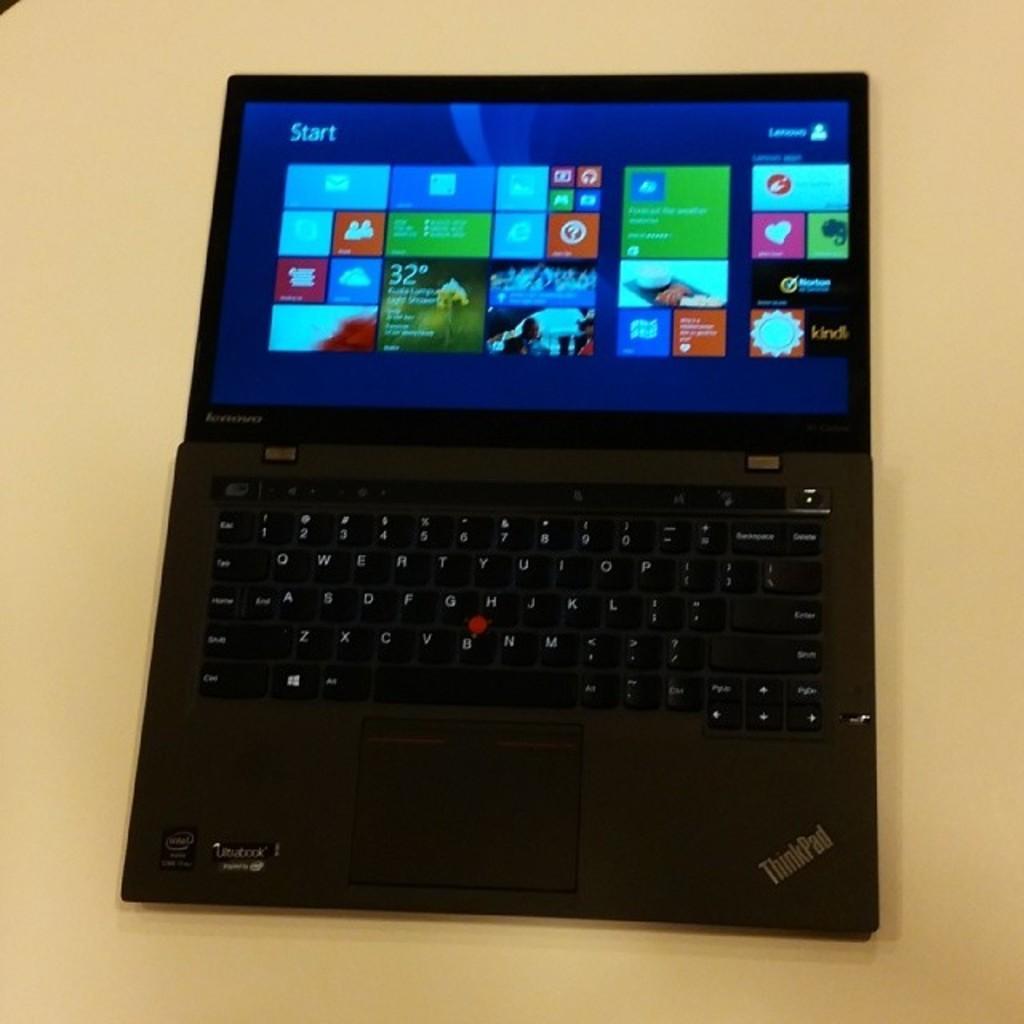Can you describe this image briefly? In the picture we can see a laptop which is placed on the cream color surface and the laptop is black in color with keys and a screen which is blue in color with some options in it. 